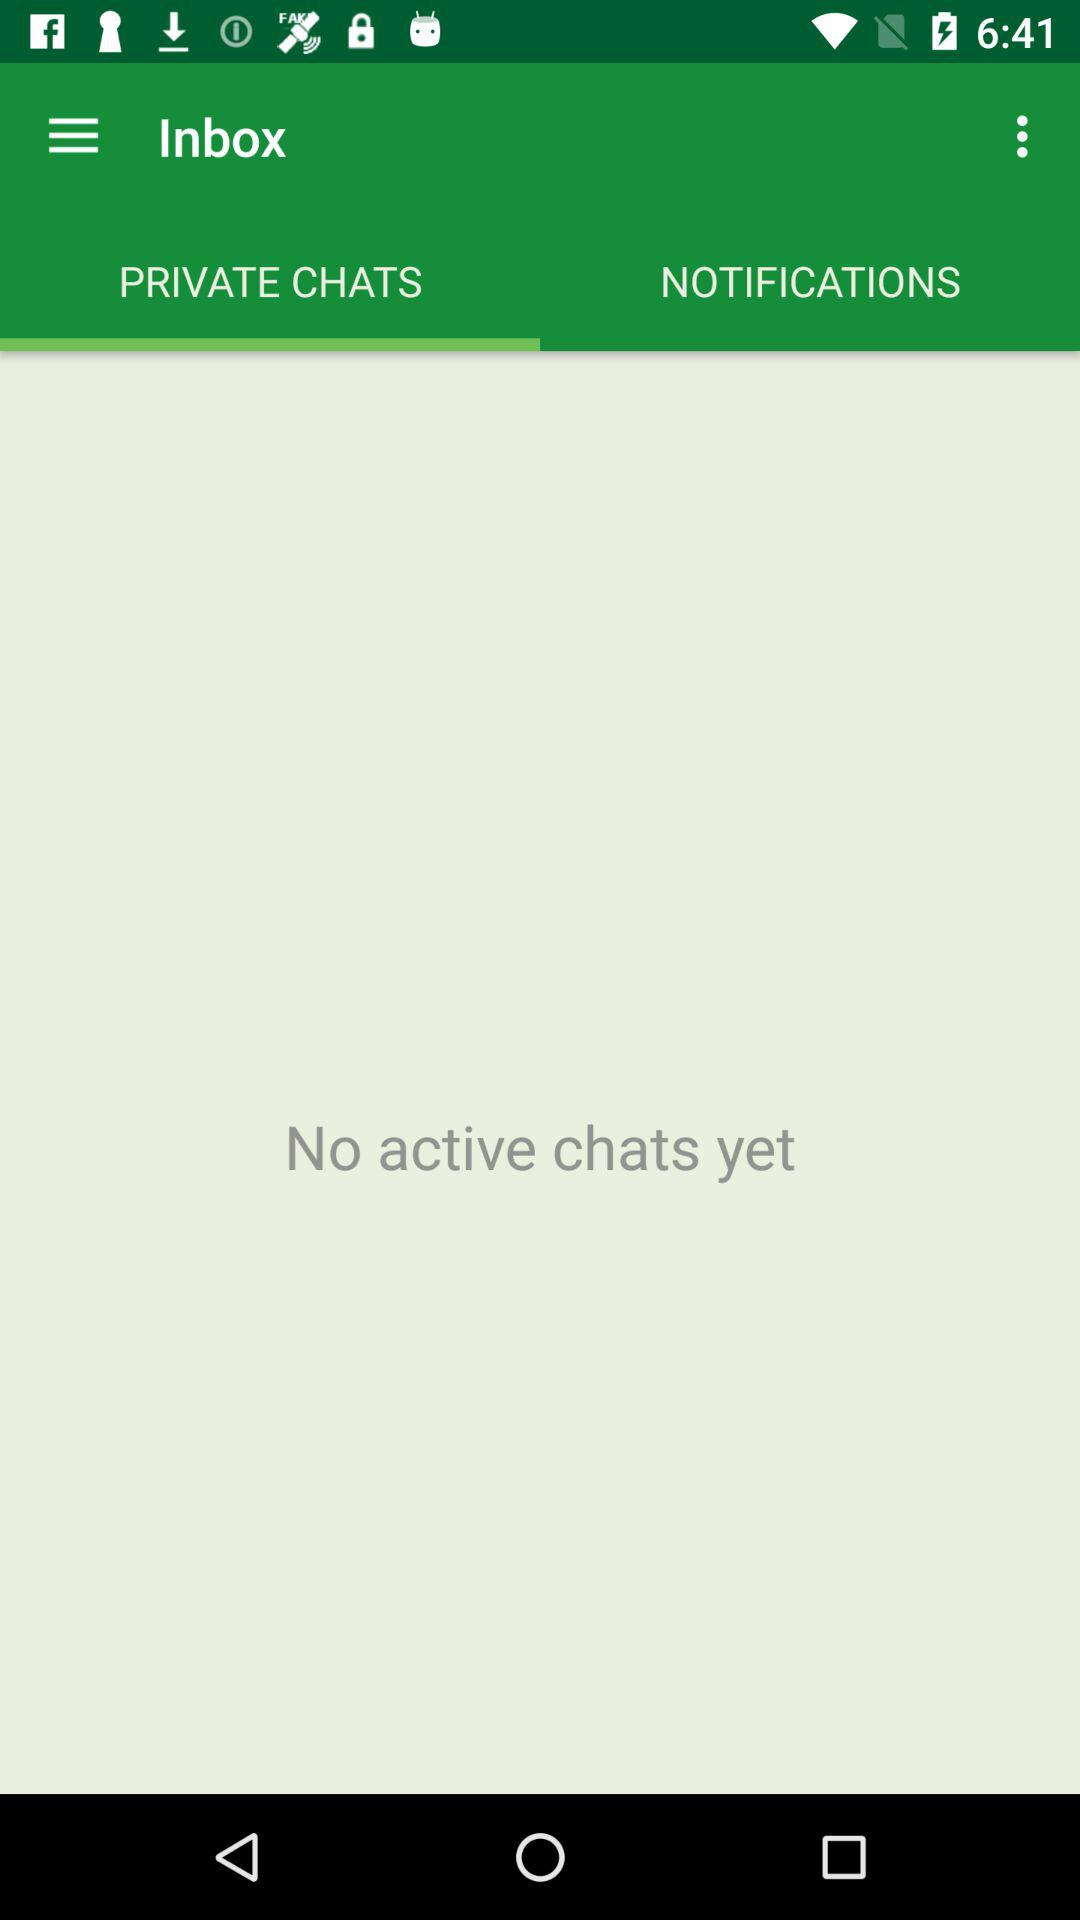Which notifications are listed?
When the provided information is insufficient, respond with <no answer>. <no answer> 